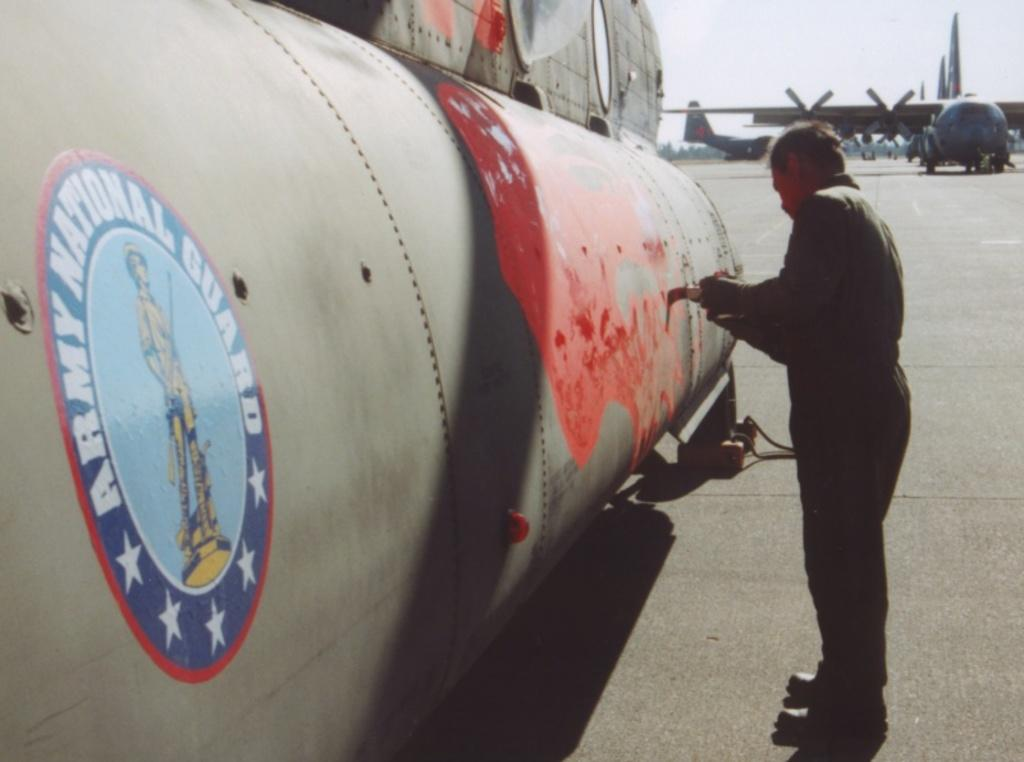<image>
Write a terse but informative summary of the picture. A painter touches up a plane belonging to the army. 